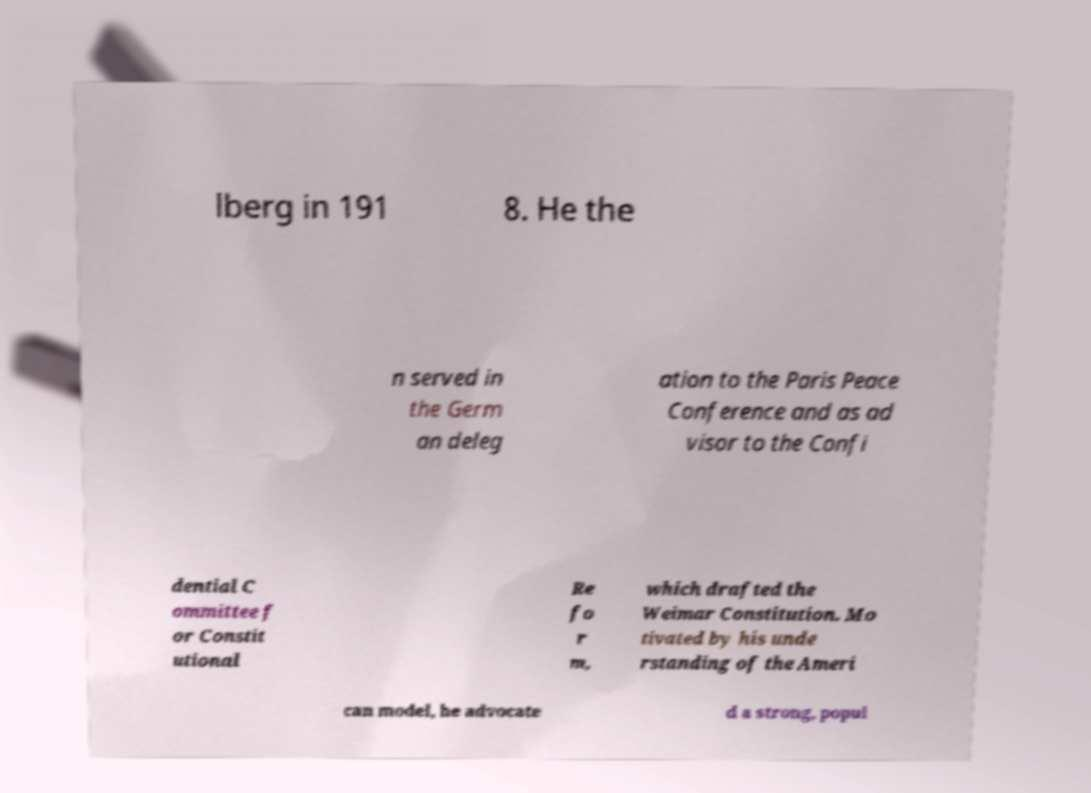For documentation purposes, I need the text within this image transcribed. Could you provide that? lberg in 191 8. He the n served in the Germ an deleg ation to the Paris Peace Conference and as ad visor to the Confi dential C ommittee f or Constit utional Re fo r m, which drafted the Weimar Constitution. Mo tivated by his unde rstanding of the Ameri can model, he advocate d a strong, popul 